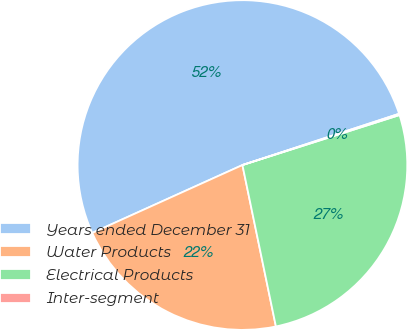<chart> <loc_0><loc_0><loc_500><loc_500><pie_chart><fcel>Years ended December 31<fcel>Water Products<fcel>Electrical Products<fcel>Inter-segment<nl><fcel>51.72%<fcel>21.5%<fcel>26.65%<fcel>0.13%<nl></chart> 